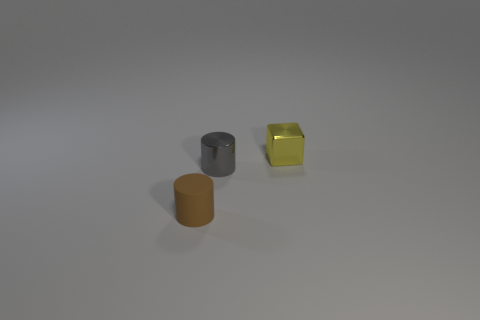Subtract all gray cylinders. How many cylinders are left? 1 Subtract all blocks. How many objects are left? 2 Subtract all brown rubber things. Subtract all brown cylinders. How many objects are left? 1 Add 2 small metal objects. How many small metal objects are left? 4 Add 2 tiny red metal cylinders. How many tiny red metal cylinders exist? 2 Add 3 metallic cylinders. How many objects exist? 6 Subtract 0 blue blocks. How many objects are left? 3 Subtract 2 cylinders. How many cylinders are left? 0 Subtract all cyan cylinders. Subtract all gray blocks. How many cylinders are left? 2 Subtract all green blocks. How many brown cylinders are left? 1 